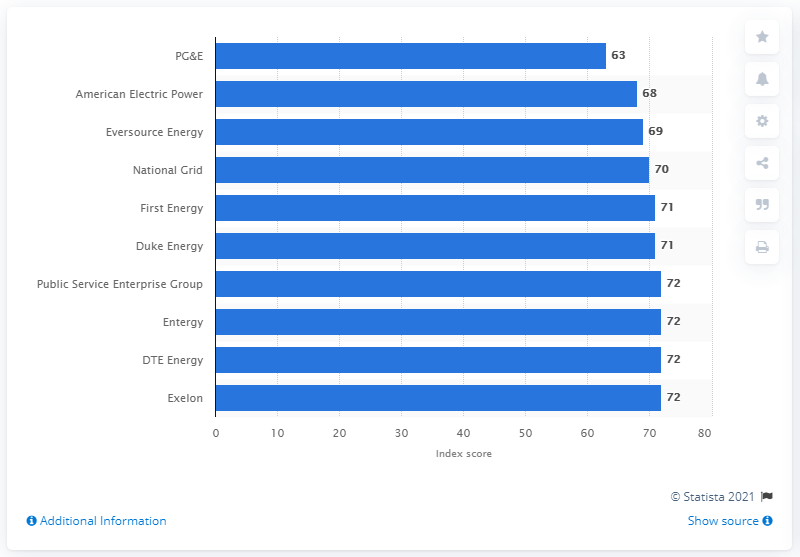Indicate a few pertinent items in this graphic. According to the American Customer Satisfaction Index in 2020, PG&E received a score of 63. 